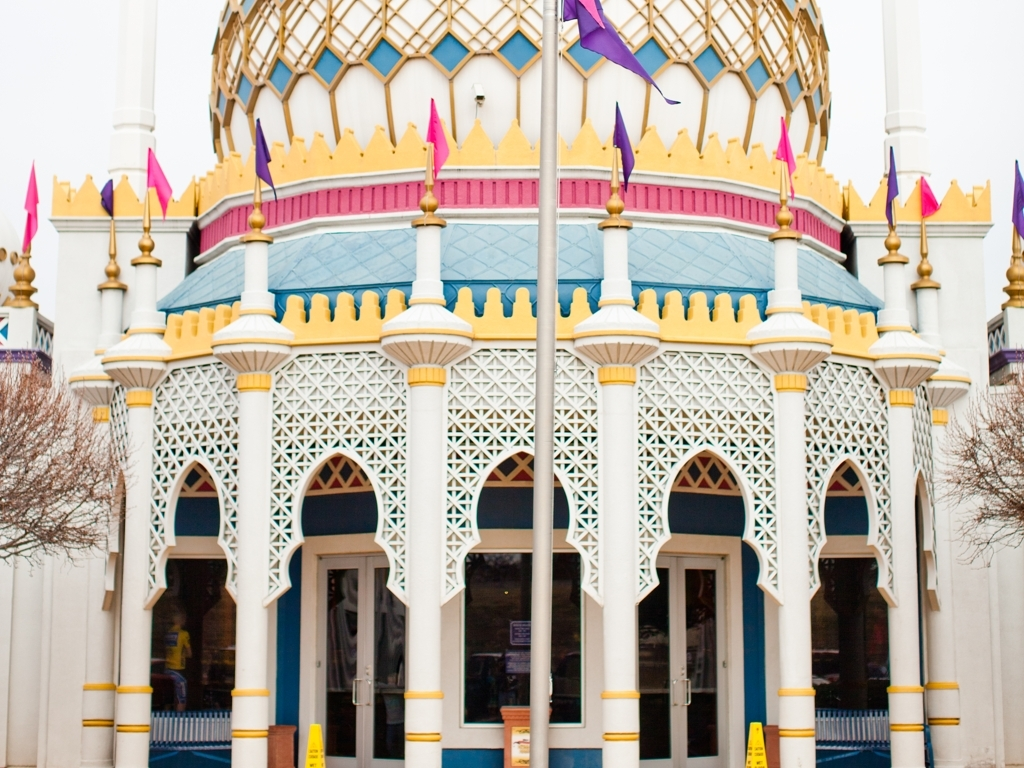Does the weather affect the photo's mood? Yes, the overcast sky creates a subdued and soft atmosphere, which contrasts with the typically bright and festive impression given by the building's design and colors. 